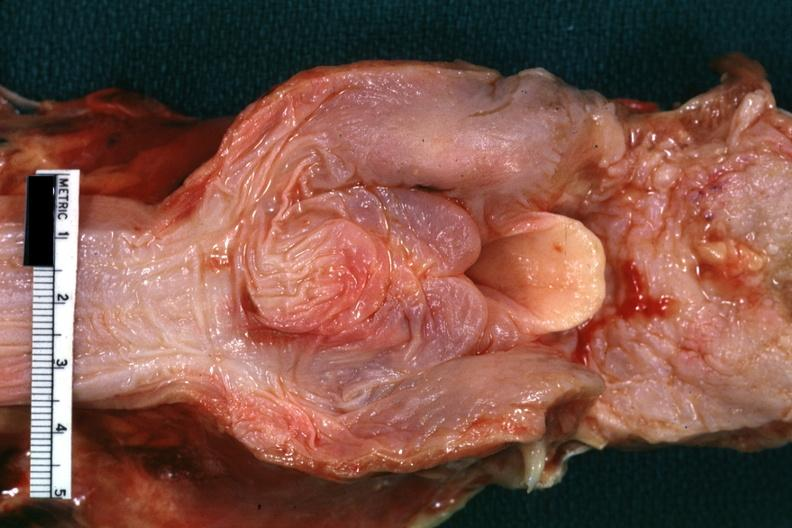what is present?
Answer the question using a single word or phrase. Oral 